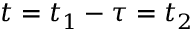Convert formula to latex. <formula><loc_0><loc_0><loc_500><loc_500>t = t _ { 1 } - \tau = t _ { 2 }</formula> 